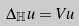<formula> <loc_0><loc_0><loc_500><loc_500>\Delta _ { \mathbb { H } } u = V u</formula> 